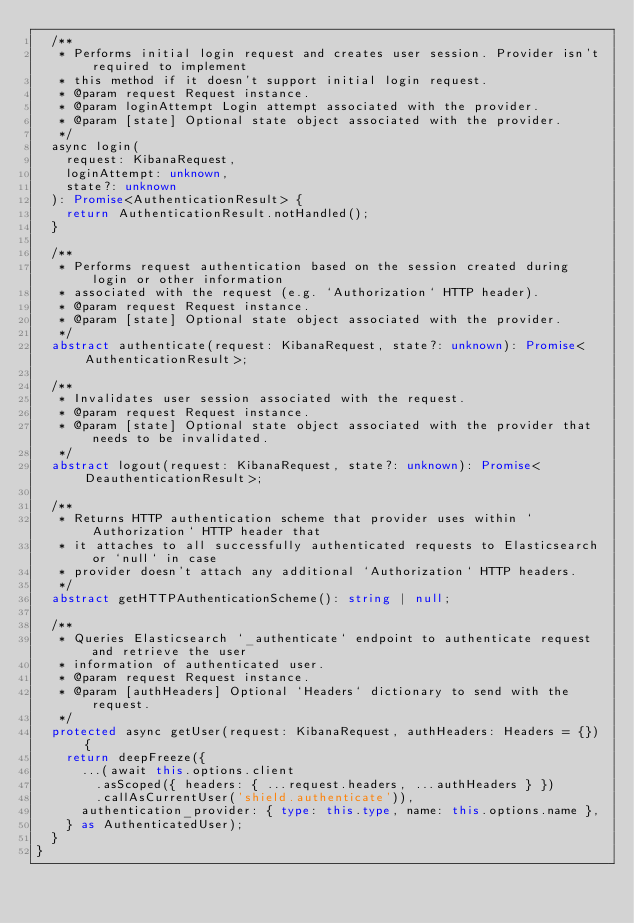Convert code to text. <code><loc_0><loc_0><loc_500><loc_500><_TypeScript_>  /**
   * Performs initial login request and creates user session. Provider isn't required to implement
   * this method if it doesn't support initial login request.
   * @param request Request instance.
   * @param loginAttempt Login attempt associated with the provider.
   * @param [state] Optional state object associated with the provider.
   */
  async login(
    request: KibanaRequest,
    loginAttempt: unknown,
    state?: unknown
  ): Promise<AuthenticationResult> {
    return AuthenticationResult.notHandled();
  }

  /**
   * Performs request authentication based on the session created during login or other information
   * associated with the request (e.g. `Authorization` HTTP header).
   * @param request Request instance.
   * @param [state] Optional state object associated with the provider.
   */
  abstract authenticate(request: KibanaRequest, state?: unknown): Promise<AuthenticationResult>;

  /**
   * Invalidates user session associated with the request.
   * @param request Request instance.
   * @param [state] Optional state object associated with the provider that needs to be invalidated.
   */
  abstract logout(request: KibanaRequest, state?: unknown): Promise<DeauthenticationResult>;

  /**
   * Returns HTTP authentication scheme that provider uses within `Authorization` HTTP header that
   * it attaches to all successfully authenticated requests to Elasticsearch or `null` in case
   * provider doesn't attach any additional `Authorization` HTTP headers.
   */
  abstract getHTTPAuthenticationScheme(): string | null;

  /**
   * Queries Elasticsearch `_authenticate` endpoint to authenticate request and retrieve the user
   * information of authenticated user.
   * @param request Request instance.
   * @param [authHeaders] Optional `Headers` dictionary to send with the request.
   */
  protected async getUser(request: KibanaRequest, authHeaders: Headers = {}) {
    return deepFreeze({
      ...(await this.options.client
        .asScoped({ headers: { ...request.headers, ...authHeaders } })
        .callAsCurrentUser('shield.authenticate')),
      authentication_provider: { type: this.type, name: this.options.name },
    } as AuthenticatedUser);
  }
}
</code> 